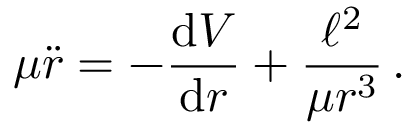<formula> <loc_0><loc_0><loc_500><loc_500>\mu { \ddot { r } } = - { \frac { d V } { d r } } + { \frac { \ell ^ { 2 } } { \mu r ^ { 3 } } } \, .</formula> 